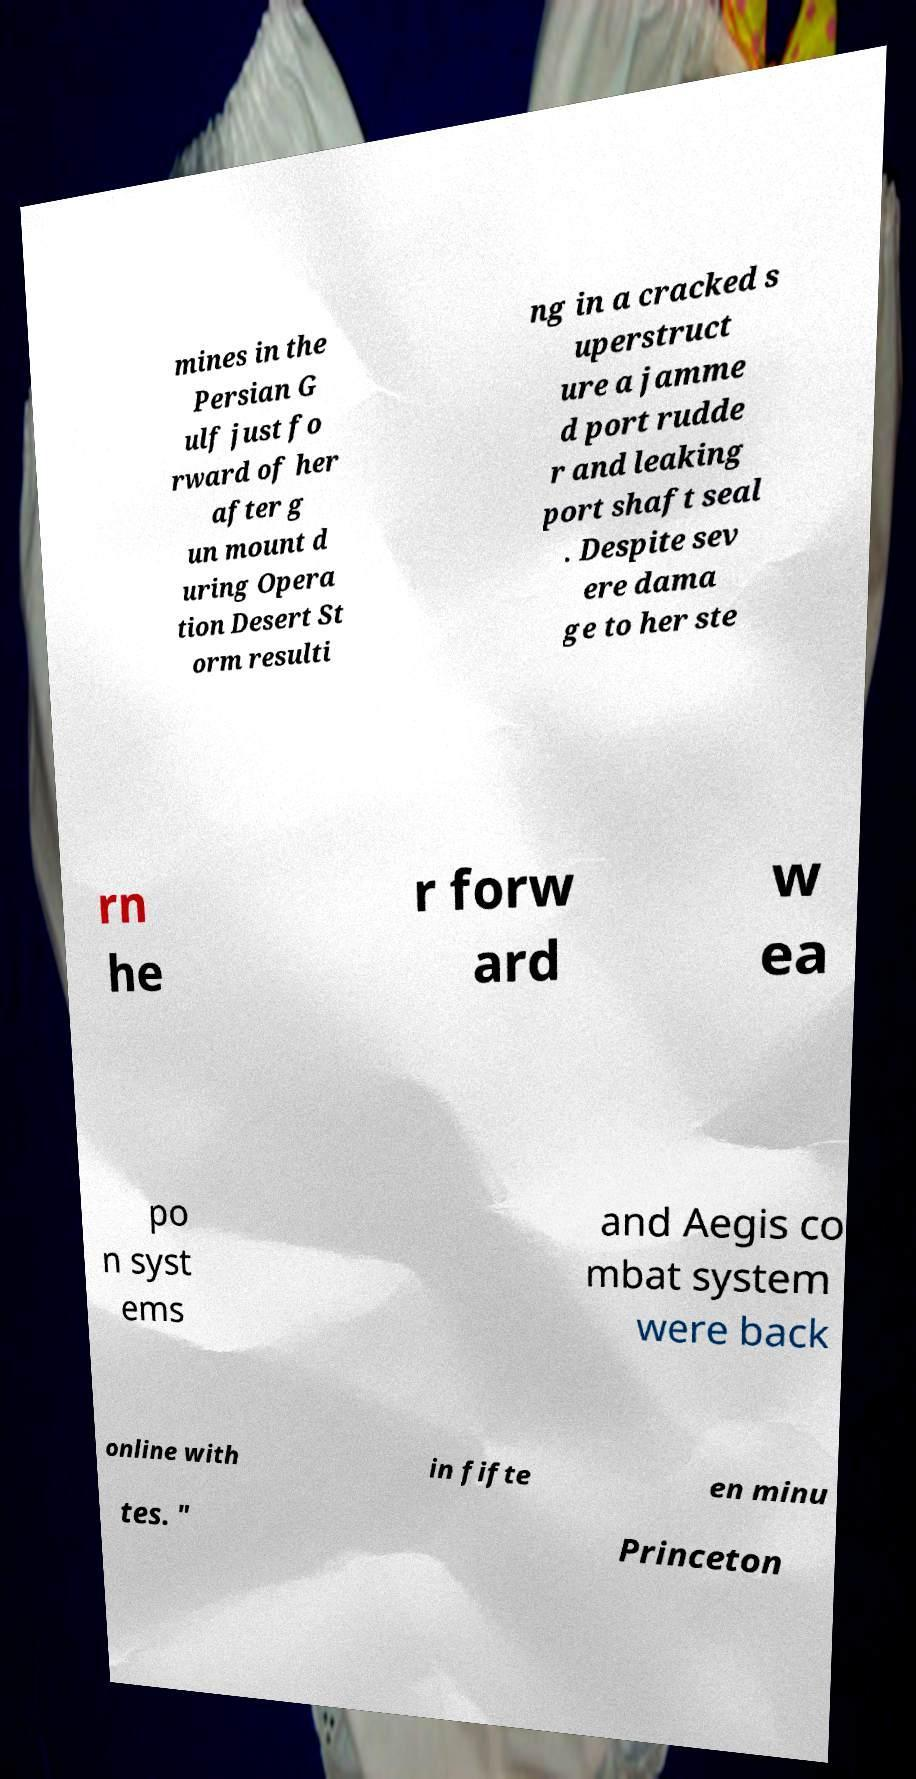There's text embedded in this image that I need extracted. Can you transcribe it verbatim? mines in the Persian G ulf just fo rward of her after g un mount d uring Opera tion Desert St orm resulti ng in a cracked s uperstruct ure a jamme d port rudde r and leaking port shaft seal . Despite sev ere dama ge to her ste rn he r forw ard w ea po n syst ems and Aegis co mbat system were back online with in fifte en minu tes. " Princeton 